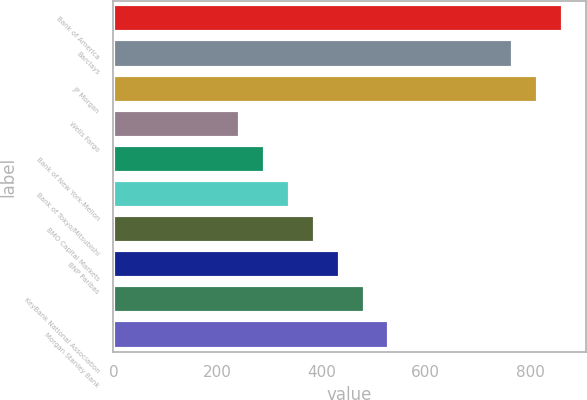<chart> <loc_0><loc_0><loc_500><loc_500><bar_chart><fcel>Bank of America<fcel>Barclays<fcel>JP Morgan<fcel>Wells Fargo<fcel>Bank of New York-Mellon<fcel>Bank of Tokyo/Mitsubishi<fcel>BMO Capital Markets<fcel>BNP Paribas<fcel>KeyBank National Association<fcel>Morgan Stanley Bank<nl><fcel>863.61<fcel>768.27<fcel>815.94<fcel>243.9<fcel>291.57<fcel>339.24<fcel>386.91<fcel>434.58<fcel>482.25<fcel>529.92<nl></chart> 